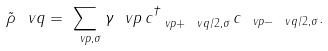<formula> <loc_0><loc_0><loc_500><loc_500>\tilde { \rho } _ { \ } v q = \sum _ { \ v p , \sigma } \gamma _ { \ } v p \, c ^ { \dag } _ { \ v p + \ v q / 2 , \sigma } \, c _ { \ v p - \ v q / 2 , \sigma } .</formula> 